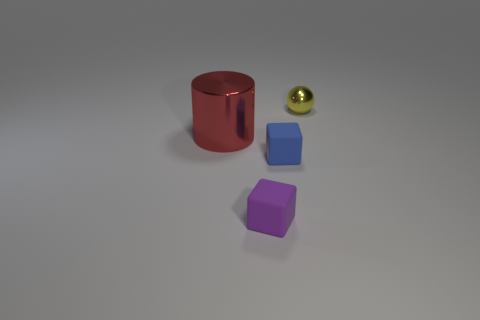There is a blue rubber thing; does it have the same shape as the tiny matte object left of the blue rubber cube? The blue rubber item appears to be a cube, and based on the image, it indeed has the same geometrical shape as the tiny matte object to its left, which is also a cube, albeit smaller and with a different texture and color. 